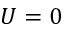<formula> <loc_0><loc_0><loc_500><loc_500>U = 0</formula> 